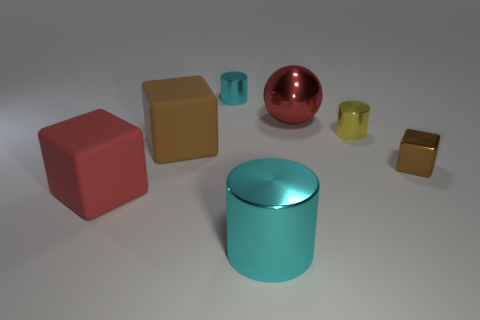Add 3 small blue metallic cylinders. How many objects exist? 10 Subtract all balls. How many objects are left? 6 Subtract all small yellow cylinders. Subtract all red spheres. How many objects are left? 5 Add 6 large cyan metal cylinders. How many large cyan metal cylinders are left? 7 Add 3 small cyan things. How many small cyan things exist? 4 Subtract 0 purple spheres. How many objects are left? 7 